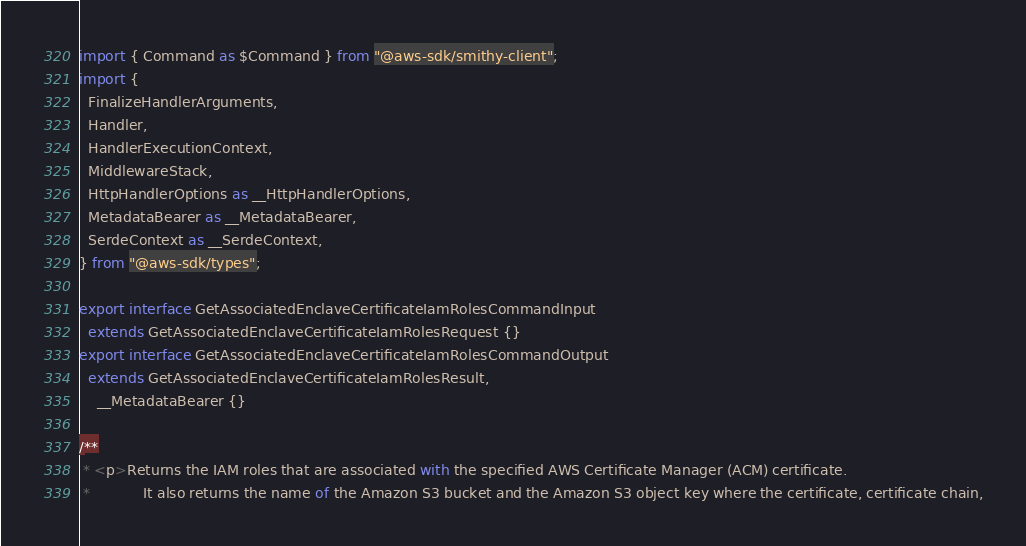Convert code to text. <code><loc_0><loc_0><loc_500><loc_500><_TypeScript_>import { Command as $Command } from "@aws-sdk/smithy-client";
import {
  FinalizeHandlerArguments,
  Handler,
  HandlerExecutionContext,
  MiddlewareStack,
  HttpHandlerOptions as __HttpHandlerOptions,
  MetadataBearer as __MetadataBearer,
  SerdeContext as __SerdeContext,
} from "@aws-sdk/types";

export interface GetAssociatedEnclaveCertificateIamRolesCommandInput
  extends GetAssociatedEnclaveCertificateIamRolesRequest {}
export interface GetAssociatedEnclaveCertificateIamRolesCommandOutput
  extends GetAssociatedEnclaveCertificateIamRolesResult,
    __MetadataBearer {}

/**
 * <p>Returns the IAM roles that are associated with the specified AWS Certificate Manager (ACM) certificate.
 * 			It also returns the name of the Amazon S3 bucket and the Amazon S3 object key where the certificate, certificate chain,</code> 